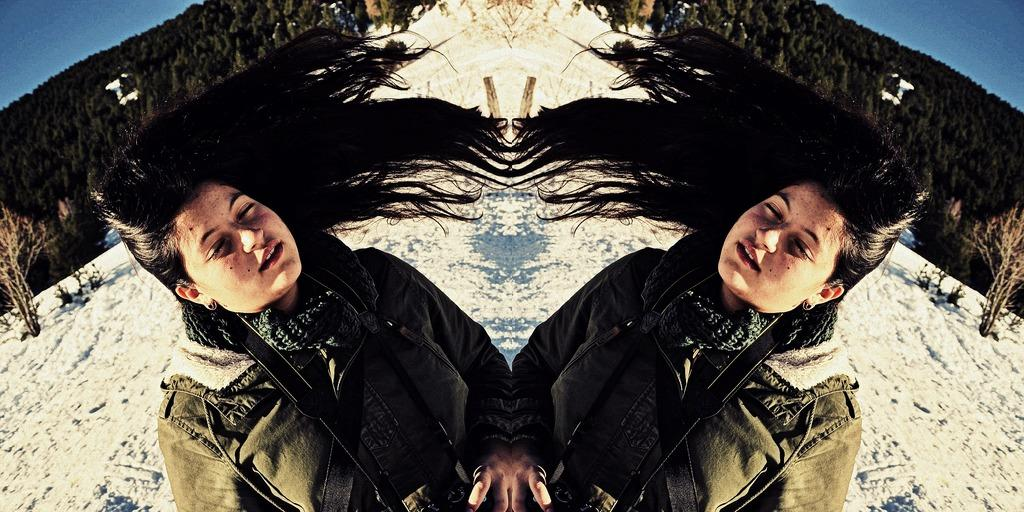Who is present in the image? There is a woman in the image. Can you describe the woman's position in the image? The woman appears on both sides of the image. What can be seen in the background of the image? There is snow, trees, a hill, and the sky visible in the background of the image. What type of mark can be seen on the clam in the image? There is no clam present in the image, so it is not possible to determine if there is a mark on it. 